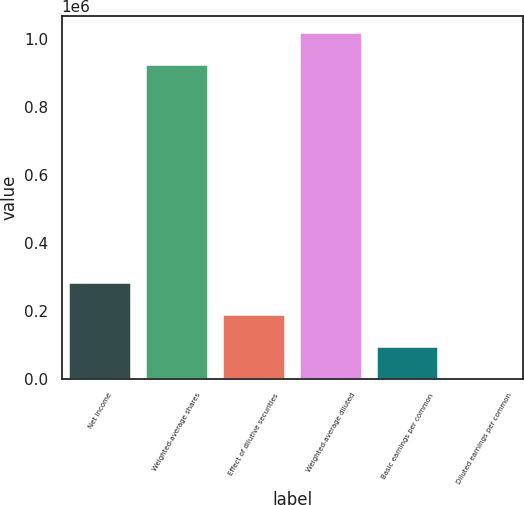Convert chart. <chart><loc_0><loc_0><loc_500><loc_500><bar_chart><fcel>Net income<fcel>Weighted-average shares<fcel>Effect of dilutive securities<fcel>Weighted-average diluted<fcel>Basic earnings per common<fcel>Diluted earnings per common<nl><fcel>281013<fcel>924258<fcel>187351<fcel>1.01792e+06<fcel>93689.4<fcel>27.68<nl></chart> 